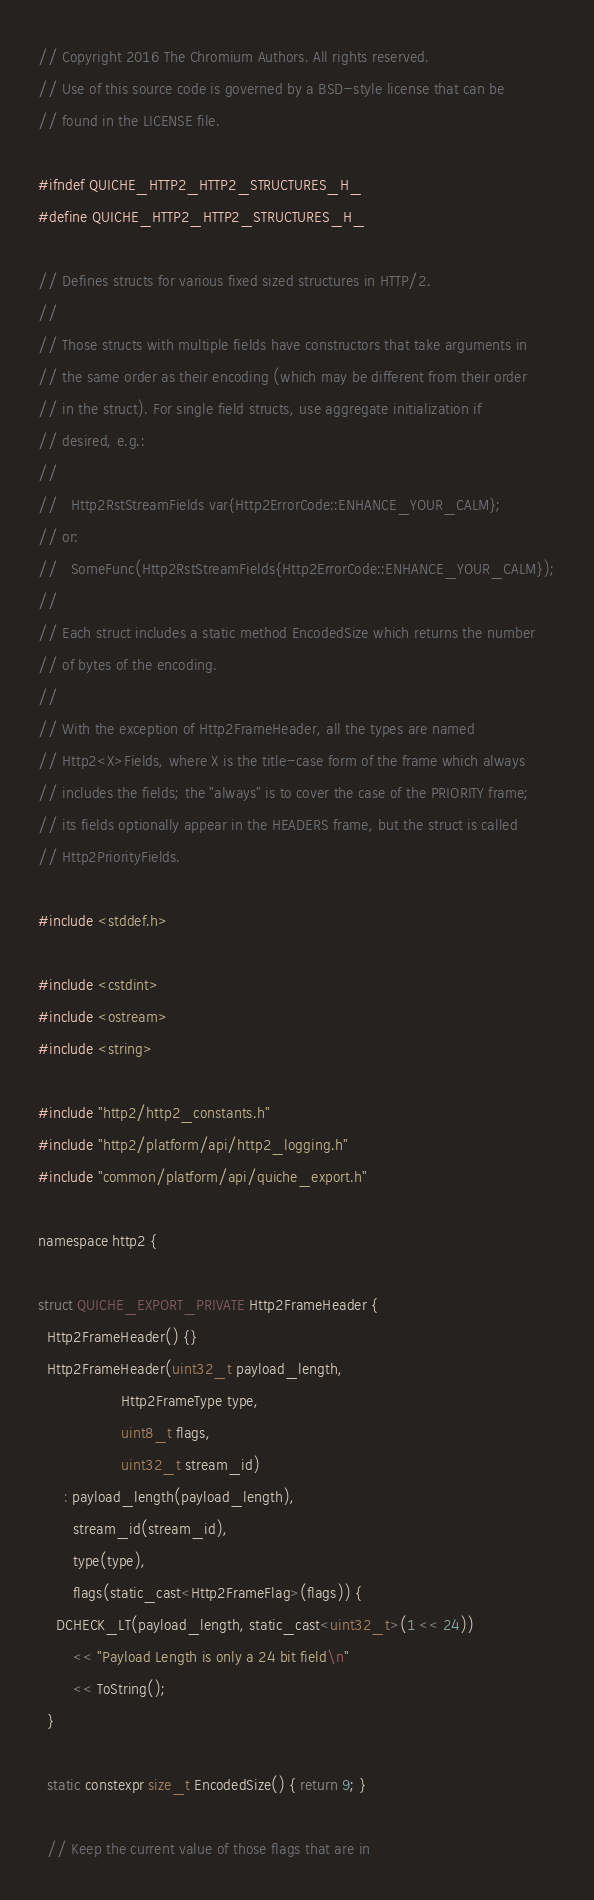Convert code to text. <code><loc_0><loc_0><loc_500><loc_500><_C_>// Copyright 2016 The Chromium Authors. All rights reserved.
// Use of this source code is governed by a BSD-style license that can be
// found in the LICENSE file.

#ifndef QUICHE_HTTP2_HTTP2_STRUCTURES_H_
#define QUICHE_HTTP2_HTTP2_STRUCTURES_H_

// Defines structs for various fixed sized structures in HTTP/2.
//
// Those structs with multiple fields have constructors that take arguments in
// the same order as their encoding (which may be different from their order
// in the struct). For single field structs, use aggregate initialization if
// desired, e.g.:
//
//   Http2RstStreamFields var{Http2ErrorCode::ENHANCE_YOUR_CALM};
// or:
//   SomeFunc(Http2RstStreamFields{Http2ErrorCode::ENHANCE_YOUR_CALM});
//
// Each struct includes a static method EncodedSize which returns the number
// of bytes of the encoding.
//
// With the exception of Http2FrameHeader, all the types are named
// Http2<X>Fields, where X is the title-case form of the frame which always
// includes the fields; the "always" is to cover the case of the PRIORITY frame;
// its fields optionally appear in the HEADERS frame, but the struct is called
// Http2PriorityFields.

#include <stddef.h>

#include <cstdint>
#include <ostream>
#include <string>

#include "http2/http2_constants.h"
#include "http2/platform/api/http2_logging.h"
#include "common/platform/api/quiche_export.h"

namespace http2 {

struct QUICHE_EXPORT_PRIVATE Http2FrameHeader {
  Http2FrameHeader() {}
  Http2FrameHeader(uint32_t payload_length,
                   Http2FrameType type,
                   uint8_t flags,
                   uint32_t stream_id)
      : payload_length(payload_length),
        stream_id(stream_id),
        type(type),
        flags(static_cast<Http2FrameFlag>(flags)) {
    DCHECK_LT(payload_length, static_cast<uint32_t>(1 << 24))
        << "Payload Length is only a 24 bit field\n"
        << ToString();
  }

  static constexpr size_t EncodedSize() { return 9; }

  // Keep the current value of those flags that are in</code> 